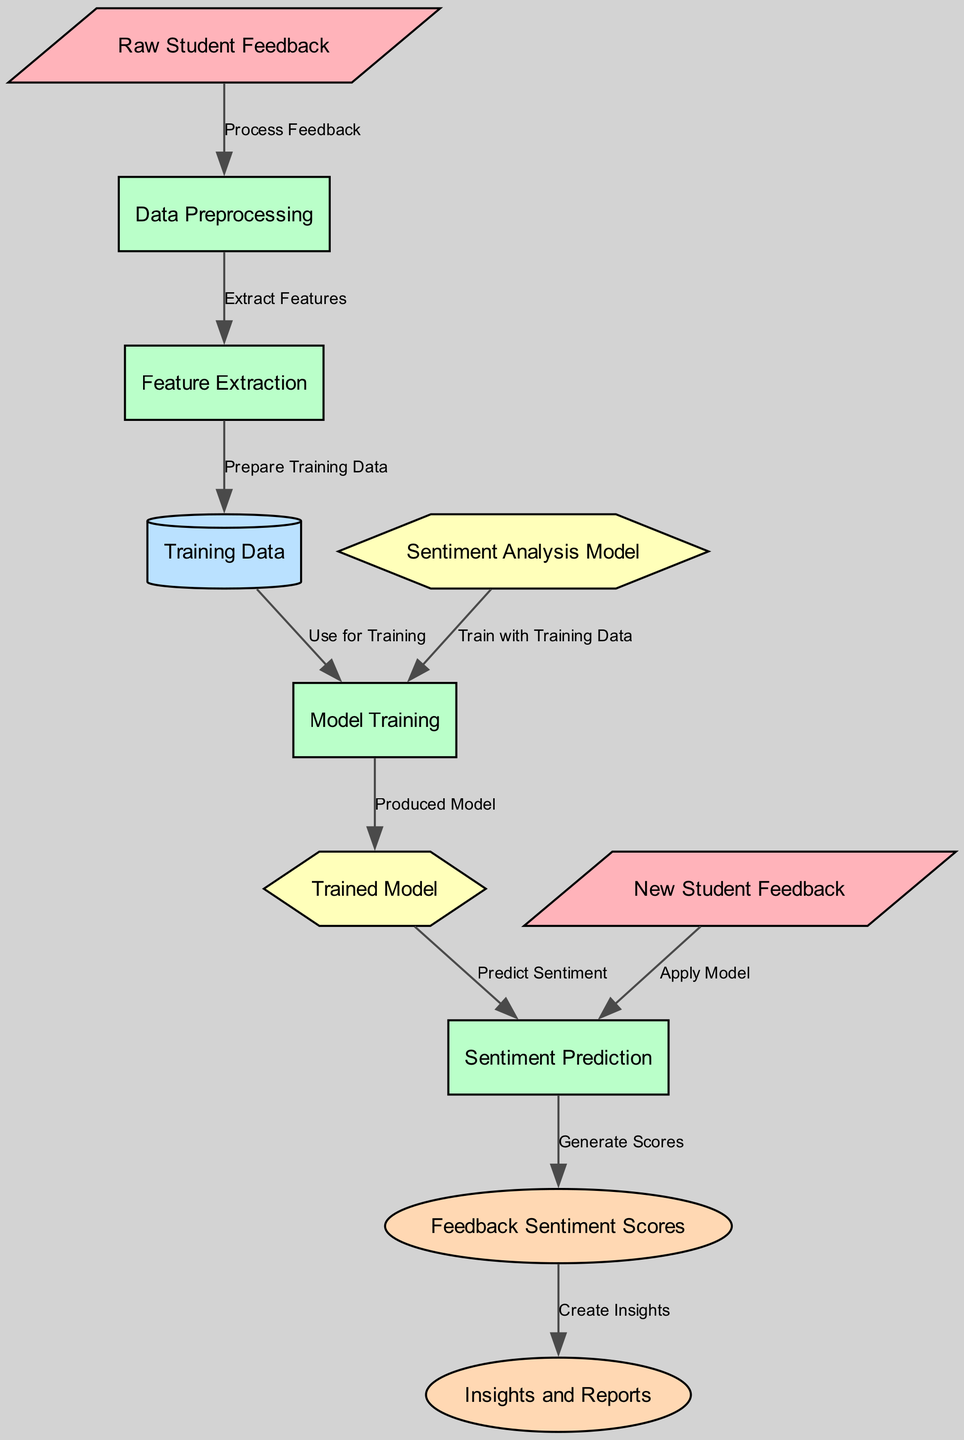What is the starting point of the diagram? The starting point of the diagram is the node labeled "Raw Student Feedback," which represents the initial collection of feedback for processing.
Answer: Raw Student Feedback How many types of nodes are present in the diagram? The diagram includes five types of nodes: input, process, data, model, and output. By counting each unique type in the node definitions, we find there are five types.
Answer: Five Which node receives the "Training Data"? The "Training Data" is received by the "Model Training" node, as indicated by the directed edge labeled "Use for Training" from the "Training Data" node to the "Model Training" node.
Answer: Model Training What is the output generated from the "Sentiment Prediction" process? The output generated from the "Sentiment Prediction" process is "Feedback Sentiment Scores," where the sentiment analysis is applied to categorize sentiments.
Answer: Feedback Sentiment Scores How many edges connect the nodes in the diagram? There are ten edges connecting the nodes, as each edge represents a relationship or process flow between nodes. Counting each edge from the edges lists provides a total of ten.
Answer: Ten What type of model can be trained in this diagram? The type of model that can be trained is a "Sentiment Analysis Model," and examples include SVM, Naive Bayes, or Neural Network, as listed in the description.
Answer: Sentiment Analysis Model Which two nodes are directly connected by the edge labeled "Create Insights"? The two nodes directly connected by the edge labeled "Create Insights" are "Feedback Sentiment Scores" and "Insights and Reports," indicating that the insights are generated from the sentiment scores.
Answer: Feedback Sentiment Scores and Insights and Reports Which step directly follows "Model Training"? The step that directly follows "Model Training" is "Trained Model," where the model is produced and ready to make predictions after completing the training.
Answer: Trained Model What does the "Data Preprocessing" node entail? The "Data Preprocessing" node entails tasks such as text cleaning, tokenization, and stop word removal, which are essential for preparing text data for analysis.
Answer: Text cleaning, tokenization, stop word removal 